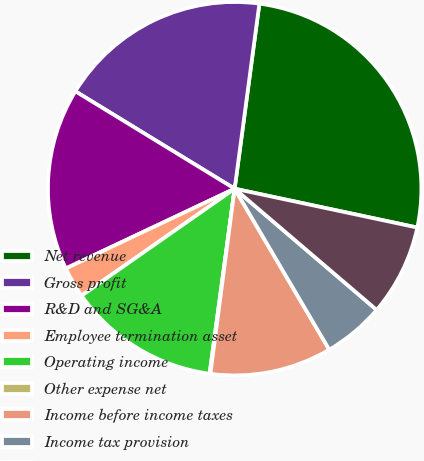Convert chart to OTSL. <chart><loc_0><loc_0><loc_500><loc_500><pie_chart><fcel>Net revenue<fcel>Gross profit<fcel>R&D and SG&A<fcel>Employee termination asset<fcel>Operating income<fcel>Other expense net<fcel>Income before income taxes<fcel>Income tax provision<fcel>Net income<nl><fcel>26.22%<fcel>18.38%<fcel>15.76%<fcel>2.68%<fcel>13.15%<fcel>0.07%<fcel>10.53%<fcel>5.3%<fcel>7.91%<nl></chart> 